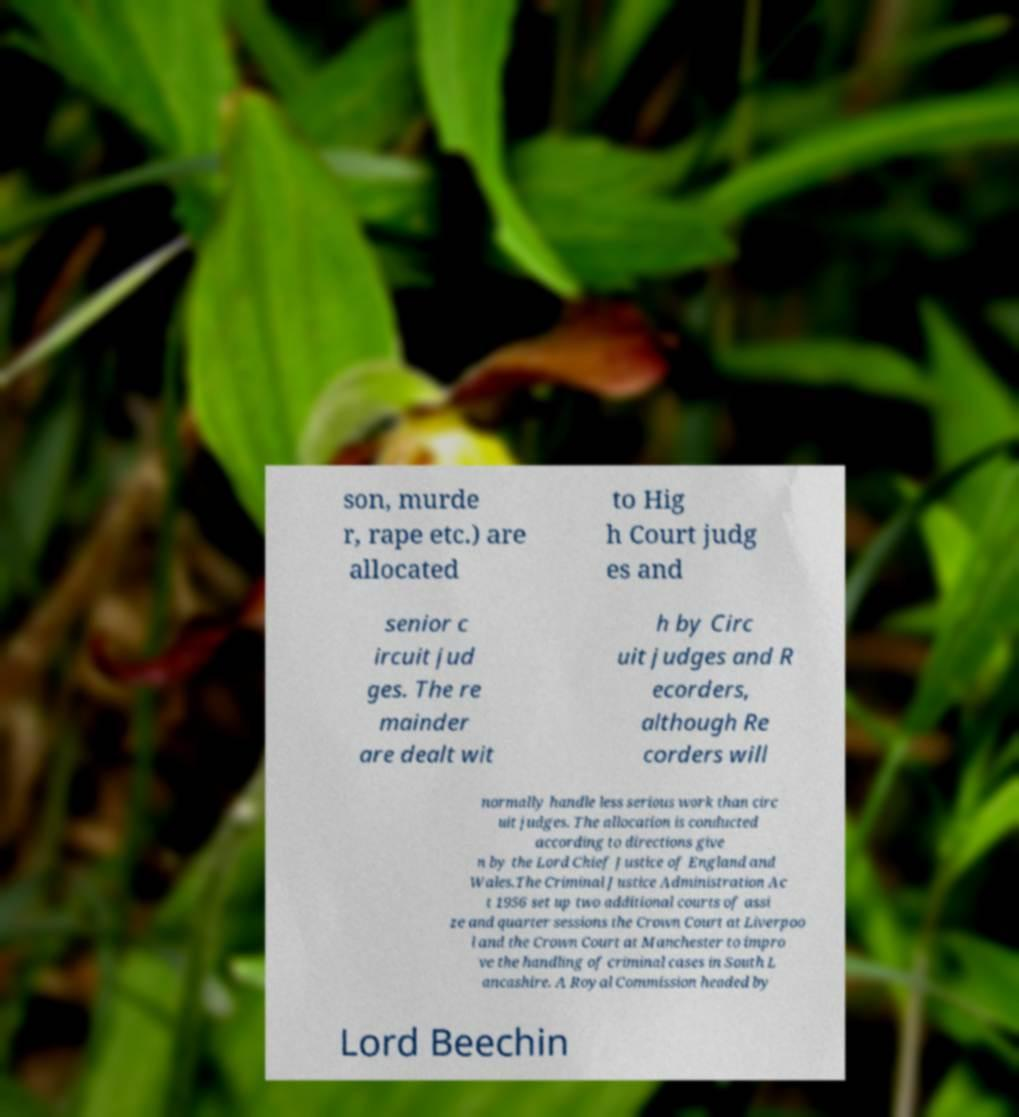What messages or text are displayed in this image? I need them in a readable, typed format. son, murde r, rape etc.) are allocated to Hig h Court judg es and senior c ircuit jud ges. The re mainder are dealt wit h by Circ uit judges and R ecorders, although Re corders will normally handle less serious work than circ uit judges. The allocation is conducted according to directions give n by the Lord Chief Justice of England and Wales.The Criminal Justice Administration Ac t 1956 set up two additional courts of assi ze and quarter sessions the Crown Court at Liverpoo l and the Crown Court at Manchester to impro ve the handling of criminal cases in South L ancashire. A Royal Commission headed by Lord Beechin 